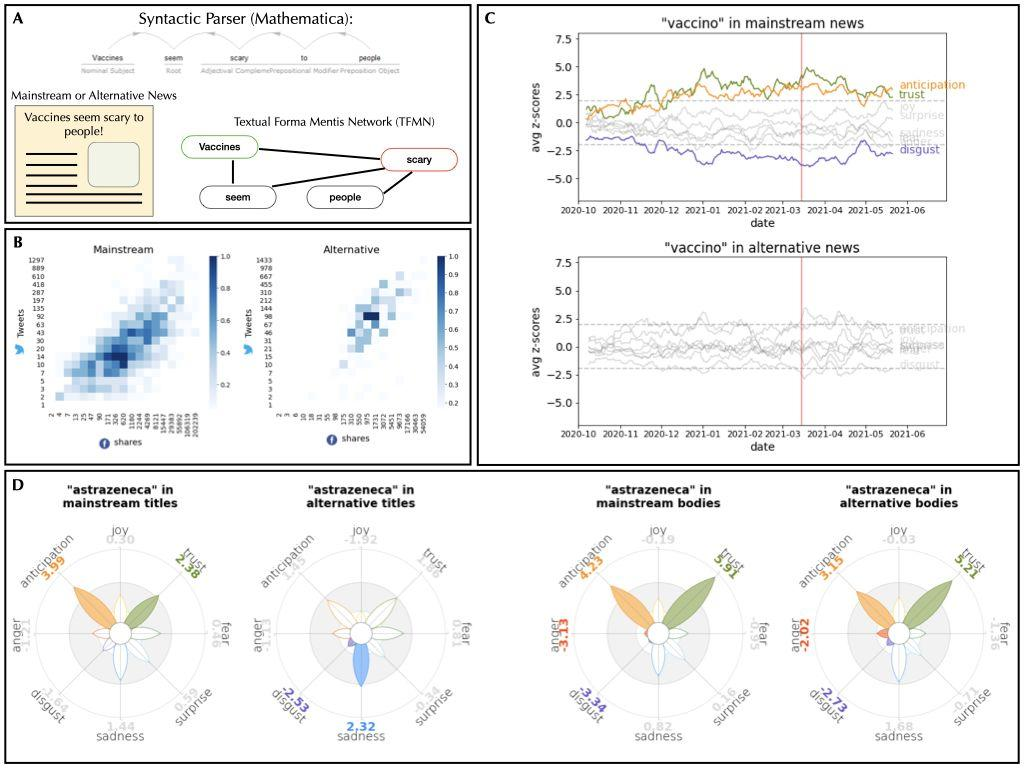Considering the temporal analyses in Figure C, how does the emotional response to the word "vaccine" evolve over time in mainstream news? Figure C displays the trend of emotional responses to the word 'vaccine' in mainstream news over time. Notably, there is an evident peak in emotions like trust and anticipation early in 2021, potentially aligned with vaccine rollout announcements or developments. This trend decreases over time, stabilizing with moderate levels of trust and anticipation. Interestingly, sadness and disgust remain relatively low throughout the period, suggesting a generally positive public perception and media representation of vaccines in mainstream channels during this phase. 